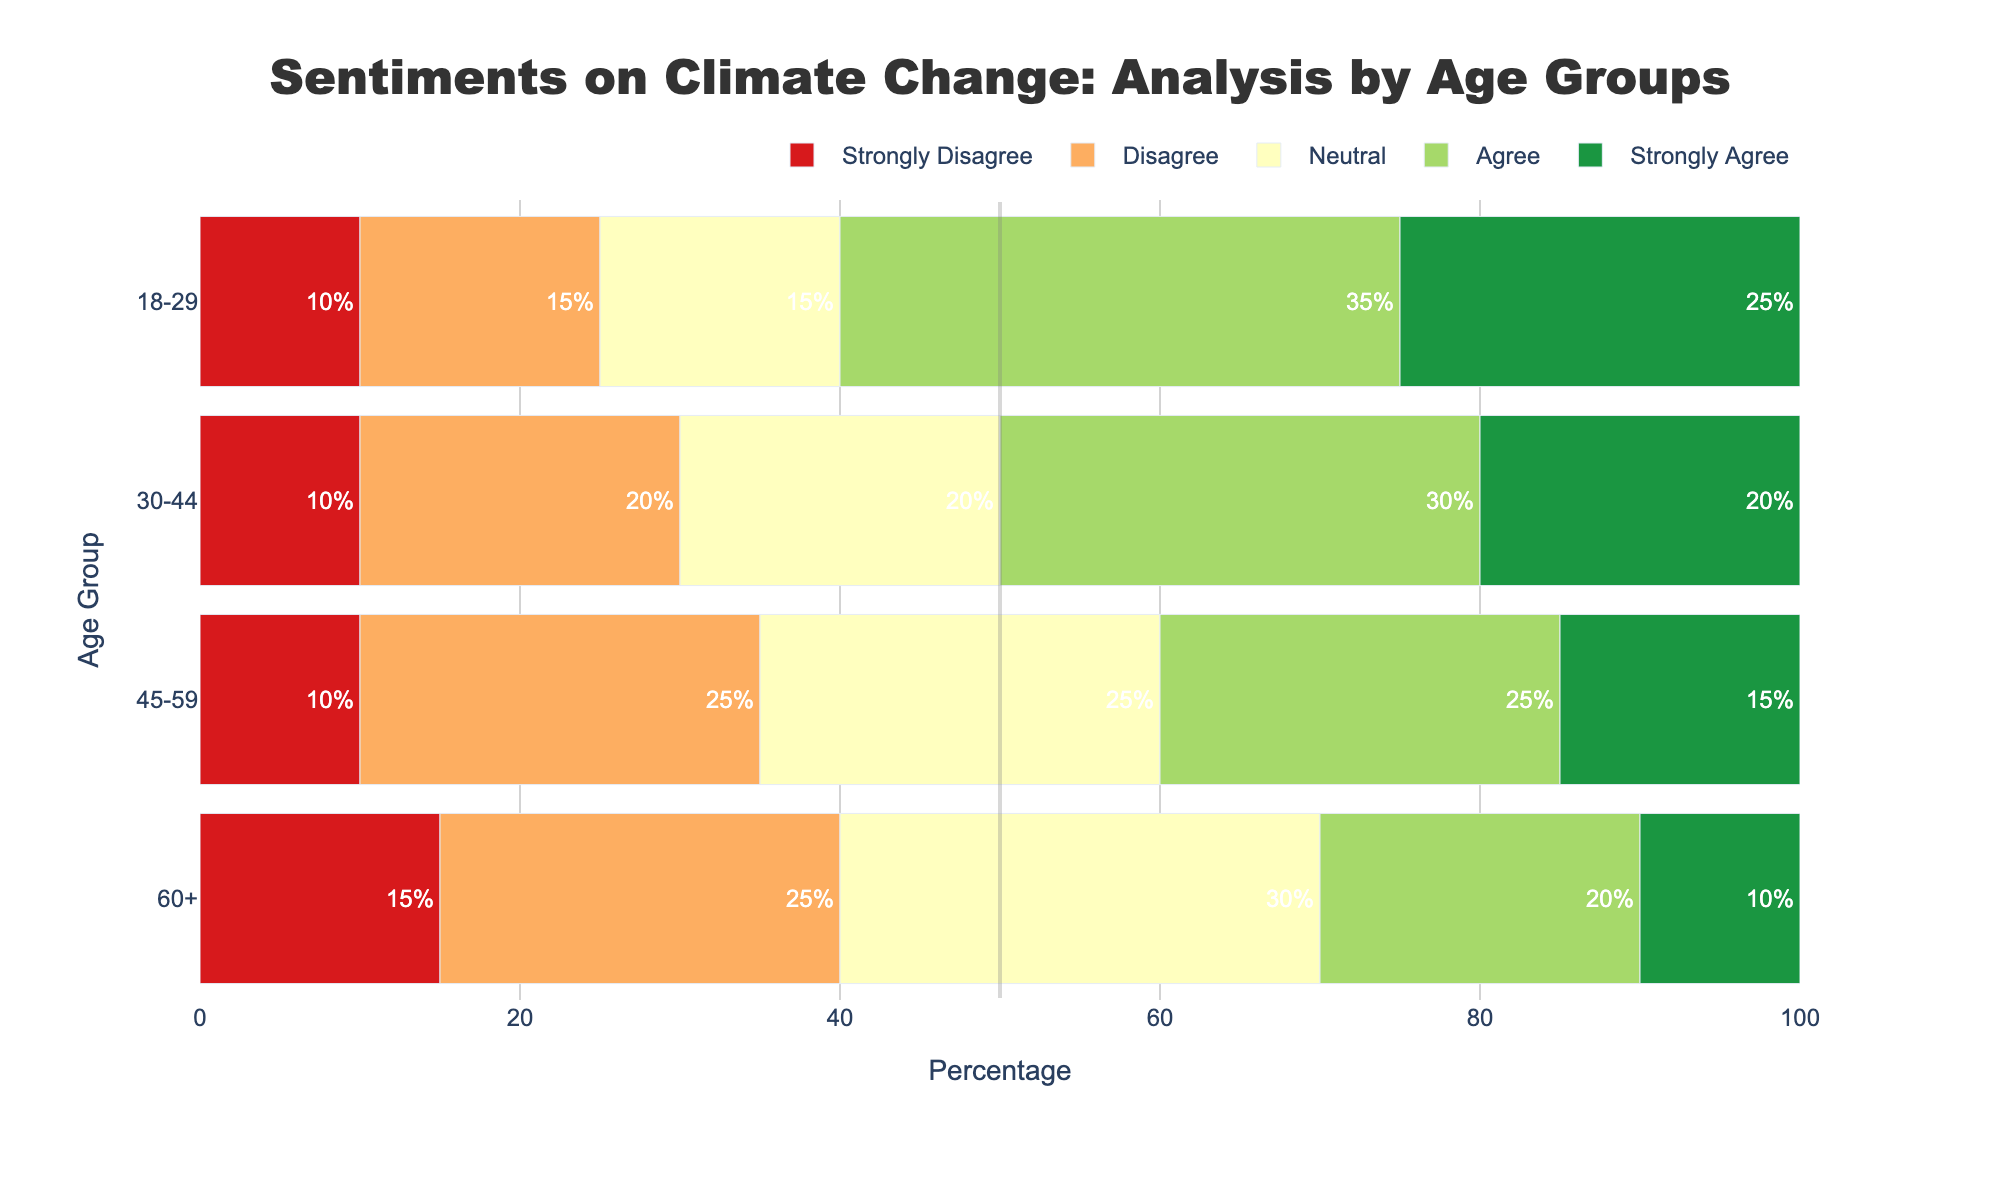What age group has the highest percentage of people who "Strongly Agree" with climate change issues? The chart has separate bars for each age group and sentiment. Examining the "Strongly Agree" bars, the 18-29 age group has the highest bar at 25%.
Answer: 18-29 Which sentiment has the least percentage in the 60+ age group? By reviewing the bar lengths for the 60+ age group, the "Strongly Agree" bar is the shortest at 10%.
Answer: Strongly Agree What is the combined percentage of people who "Agree" or "Strongly Agree" in the 30-44 age group? For the 30-44 age group, the "Agree" percentage is 30% and the "Strongly Agree" percentage is 20%. Adding them together gives 30% + 20% = 50%.
Answer: 50% How does the neutral sentiment in the 45-59 age group compare to the other age groups? Observing the lengths of the "Neutral" bars:
- 18-29: 15%
- 30-44: 20%
- 45-59: 25%
- 60+: 30%
The 45-59 group's 25% is greater than the 18-29 and 30-44 groups but less than the 60+ group.
Answer: Greater than two groups, less than one Which age group has the most diverse range of sentiments? By observing the variation in bar lengths across sentiments for each age group:
- 18-29: Ranges from 10% to 35%
- 30-44: Ranges from 10% to 30%
- 45-59: Ranges from 10% to 25%
- 60+: Ranges from 10% to 30%
The 18-29 age group has the widest range from 10% to 35%.
Answer: 18-29 Are there any age groups where "Strongly Disagree" surpasses 10%? Checking the bars for "Strongly Disagree" across age groups,
- 18-29: 10%
- 30-44: 10%
- 45-59: 10%
- 60+: 15%
Only the 60+ age group has "Strongly Disagree" surpassing 10%.
Answer: Yes, 60+ What is the mean percentage of the "Neutral" sentiment across all age groups? The "Neutral" percentages are:
- 18-29: 15%
- 30-44: 20%
- 45-59: 25%
- 60+: 30%
The mean is (15% + 20% + 25% + 30%) / 4 = 90% / 4 = 22.5%.
Answer: 22.5% Which age group is most likely to "Disagree" with statements about climate change? Observing the "Disagree" bars, the 45-59 and 60+ age groups both have the highest percentage at 25%.
Answer: 45-59 and 60+ How does the total percentage of people who are negative (Disagree + Strongly Disagree) differ between the youngest and oldest age groups? Calculating the combined percentages:
- 18-29: Disagree (15%) + Strongly Disagree (10%) = 25%
- 60+: Disagree (25%) + Strongly Disagree (15%) = 40%
The difference is 40% - 25% = 15%.
Answer: 15% Which sentiment shows the least variation in percentage across all age groups? Reviewing side-by-side bar lengths, "Strongly Disagree" shows the least variation, remaining close to 10% across the groups, except for the 60+ group with 15%.
Answer: Strongly Disagree 